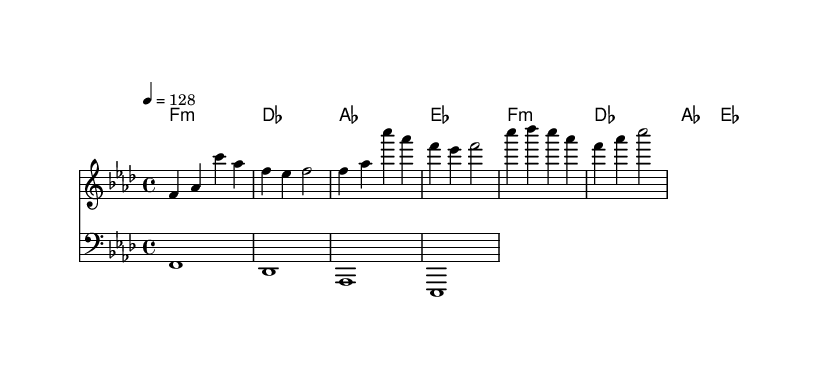What is the key signature of this music? The key signature is F minor, as indicated by the presence of four flats (B, E, A, D) in the key signature.
Answer: F minor What is the time signature of this music? The time signature shown is 4/4, which means there are four beats in each measure and a quarter note gets one beat.
Answer: 4/4 What is the tempo marking of this piece? The tempo marking indicates a speed of 128 beats per minute, as shown by the instruction “4 = 128.”
Answer: 128 How many measures are in the provided sheet music? The sheet music consists of four measures, as counted by the grouping of the notes and chords into sets of four beats each.
Answer: 4 What is the first note of the melody? The first note of the melody is F, which is the first note that appears in the melody line at the beginning of the score.
Answer: F In which clef is the melody written? The melody is written in the treble clef, which is indicated at the beginning of the melody staff.
Answer: Treble What motif can be identified from the melody? The melody showcases a repetitive pattern, primarily using the notes F, A-flat, and C, creating a recognizable motif throughout the piece.
Answer: Repetitive pattern 